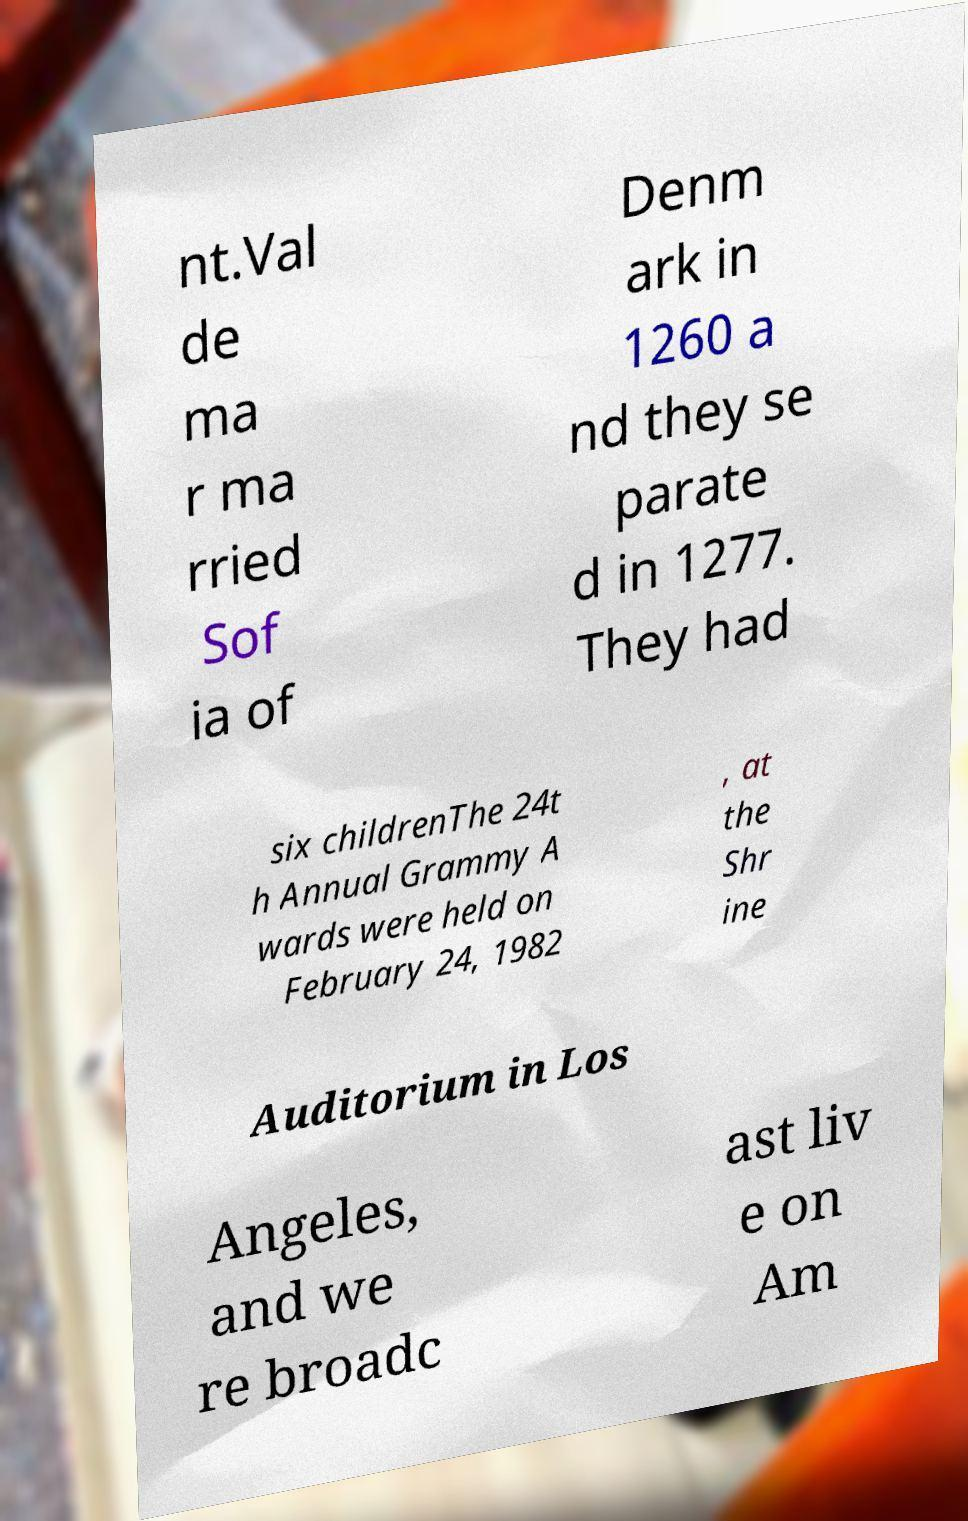Can you read and provide the text displayed in the image?This photo seems to have some interesting text. Can you extract and type it out for me? nt.Val de ma r ma rried Sof ia of Denm ark in 1260 a nd they se parate d in 1277. They had six childrenThe 24t h Annual Grammy A wards were held on February 24, 1982 , at the Shr ine Auditorium in Los Angeles, and we re broadc ast liv e on Am 